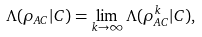<formula> <loc_0><loc_0><loc_500><loc_500>\Lambda ( \rho _ { A C } | C ) = \lim _ { k \rightarrow \infty } \Lambda ( \rho ^ { k } _ { A C } | C ) ,</formula> 